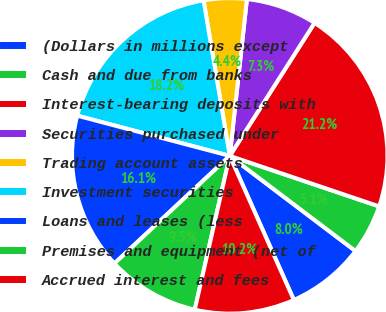<chart> <loc_0><loc_0><loc_500><loc_500><pie_chart><fcel>(Dollars in millions except<fcel>Cash and due from banks<fcel>Interest-bearing deposits with<fcel>Securities purchased under<fcel>Trading account assets<fcel>Investment securities<fcel>Loans and leases (less<fcel>Premises and equipment (net of<fcel>Accrued interest and fees<nl><fcel>8.03%<fcel>5.12%<fcel>21.15%<fcel>7.3%<fcel>4.39%<fcel>18.24%<fcel>16.05%<fcel>9.49%<fcel>10.22%<nl></chart> 